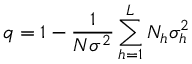<formula> <loc_0><loc_0><loc_500><loc_500>q = 1 - { \frac { 1 } { N \sigma ^ { 2 } } } \sum _ { h = 1 } ^ { L } N _ { h } \sigma _ { h } ^ { 2 }</formula> 